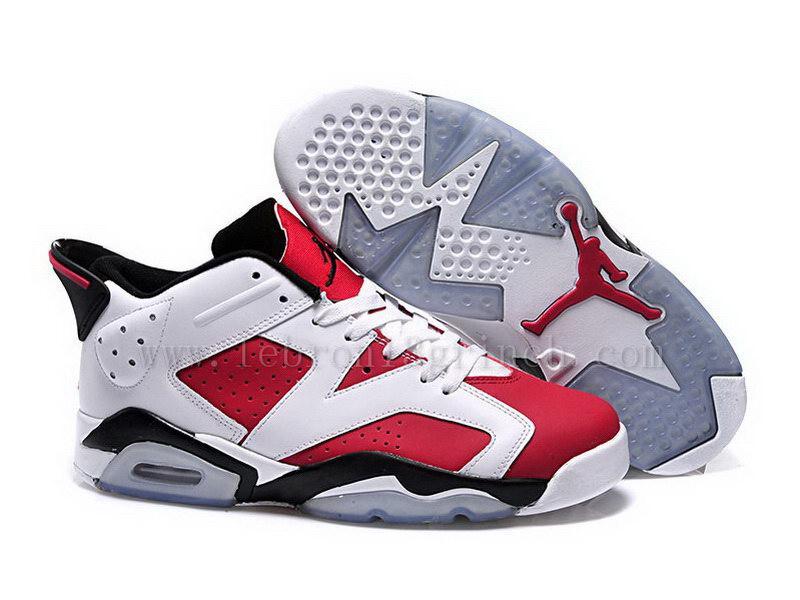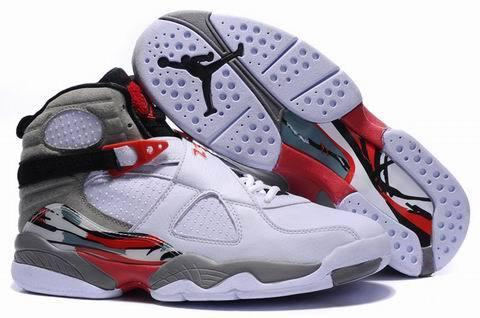The first image is the image on the left, the second image is the image on the right. Considering the images on both sides, is "At least one pair of sneakers is not shown worn by a person, and at least one pair of sneakers has red-and-white coloring." valid? Answer yes or no. Yes. The first image is the image on the left, the second image is the image on the right. Considering the images on both sides, is "At least one pair of shoes does not have any red color in it." valid? Answer yes or no. No. 